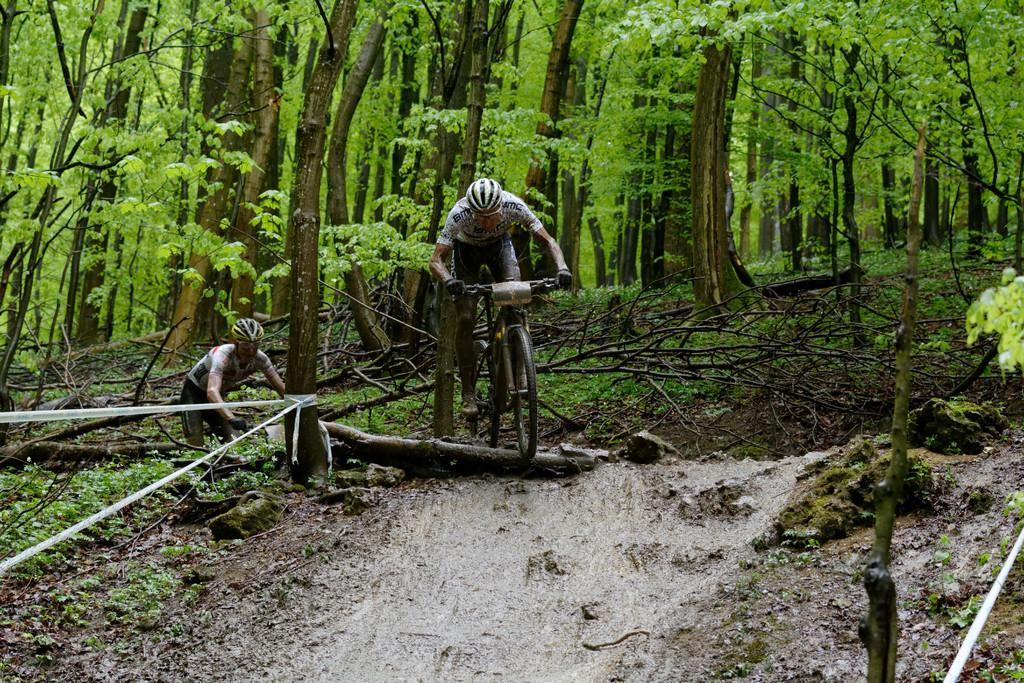What is the main subject of the image? There is a person riding a bicycle in the image. What can be seen in the background of the image? There are trees in the background of the image. What type of surface is visible at the bottom of the image? There is a road visible at the bottom of the image. What does the caption say about the person riding the bicycle in the image? There is no caption present in the image, so it is not possible to answer that question. 